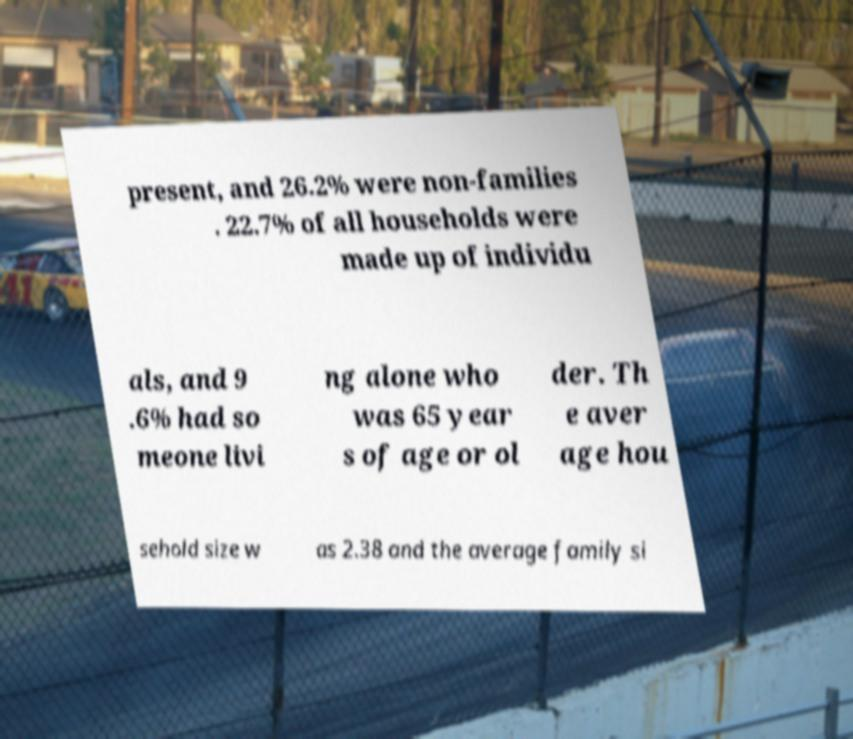Please read and relay the text visible in this image. What does it say? present, and 26.2% were non-families . 22.7% of all households were made up of individu als, and 9 .6% had so meone livi ng alone who was 65 year s of age or ol der. Th e aver age hou sehold size w as 2.38 and the average family si 